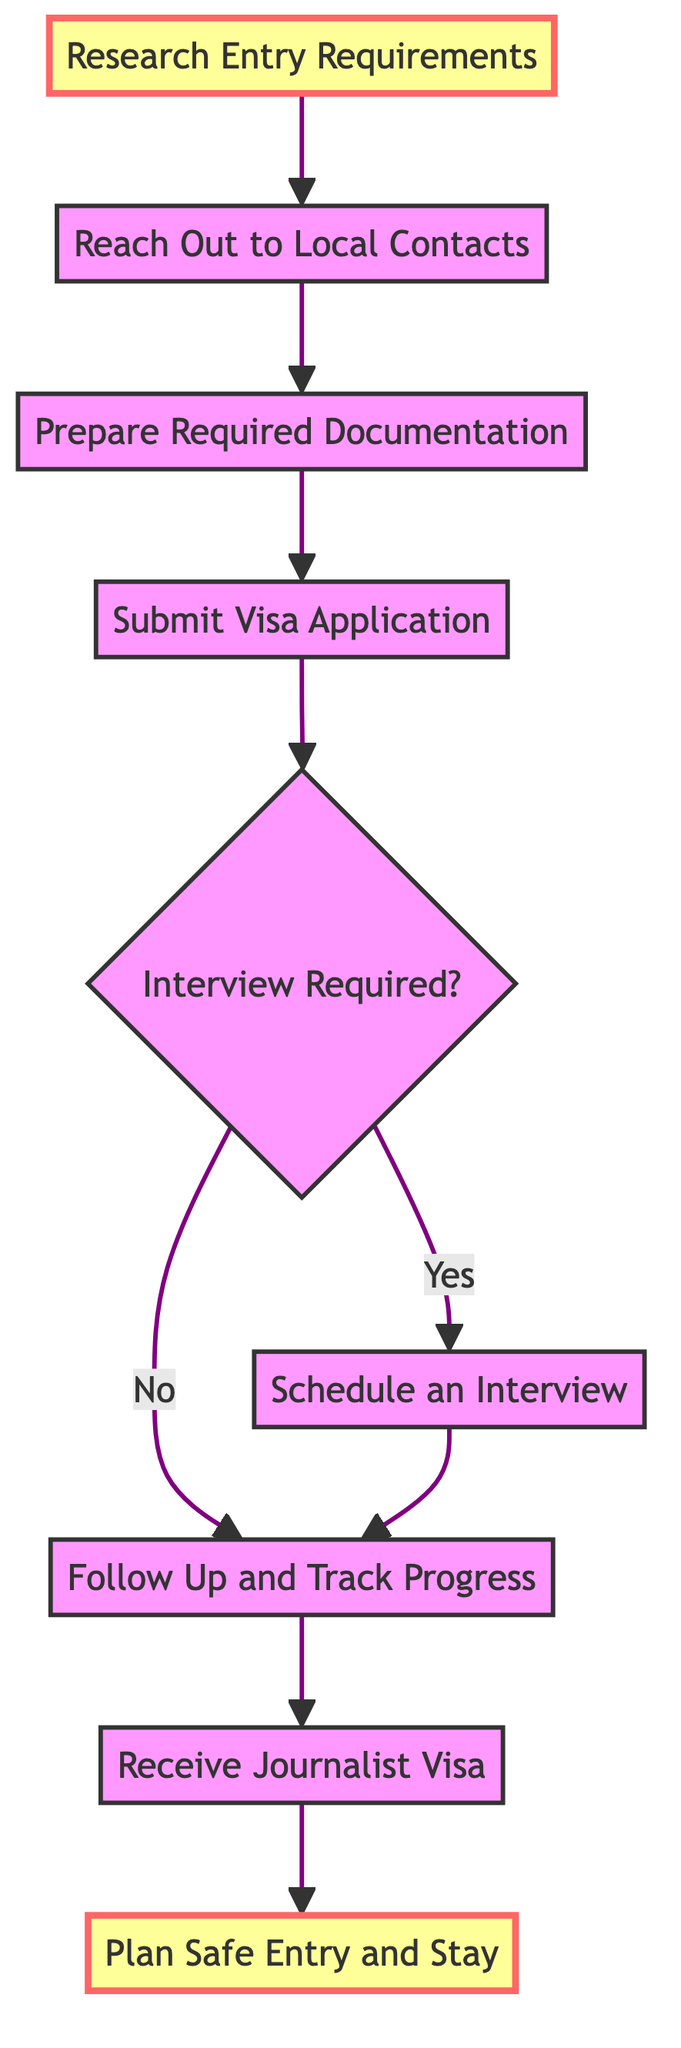What is the first step in the process? The first step in the diagram is "Research Entry Requirements." This is indicated as the starting node that flows into the next step.
Answer: Research Entry Requirements How many steps are there in total? There are eight steps represented in the diagram, from "Research Entry Requirements" to "Plan Safe Entry and Stay." Count each labeled node to confirm the total.
Answer: Eight What step follows "Prepare Required Documentation"? The step that follows "Prepare Required Documentation" is "Submit Visa Application." This is directly indicated by the arrow flowing from one node to the next in the diagram.
Answer: Submit Visa Application Is an interview always required based on the diagram? No, an interview is not always required. The diagram shows a decision point ("Interview Required?") that branches into "Yes" and "No," indicating that whether an interview is needed can vary.
Answer: No What happens after the visa application is submitted if an interview is required? If an interview is required, the next step is "Schedule an Interview." The flow indicates a clear pathway from submitting the application to scheduling the interview.
Answer: Schedule an Interview What is the relationship between "Receive Journalist Visa" and "Plan Safe Entry and Stay"? "Receive Journalist Visa" is a prerequisite step before "Plan Safe Entry and Stay." You must first receive the visa before planning your safe entry into the conflict zone, as shown by the directional flow between the two nodes.
Answer: Prerequisite If the application does not need an interview, what is the next step? If the application does not require an interview, the next step is "Follow Up and Track Progress." This is explicitly indicated in the decision path of the diagram from the "Interview Required?" node.
Answer: Follow Up and Track Progress What type of diagram is used to represent this process? The diagram used to represent this process is a flowchart. This can be identified by its directional arrows and organized steps showing a sequence or function.
Answer: Flowchart 